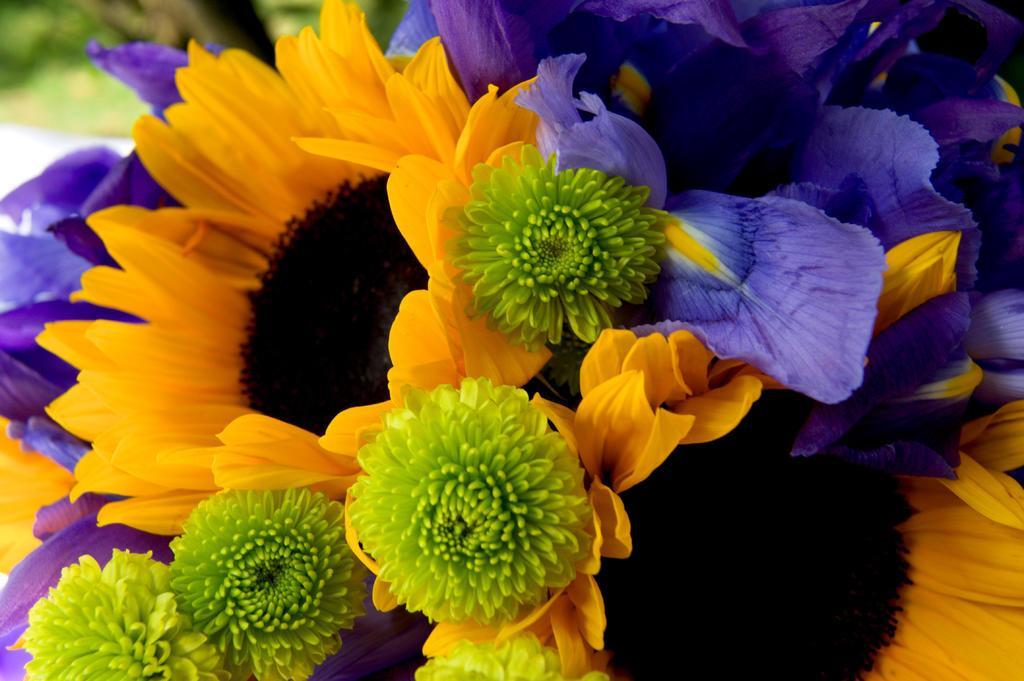How would you summarize this image in a sentence or two? In this image we can see flowers. 